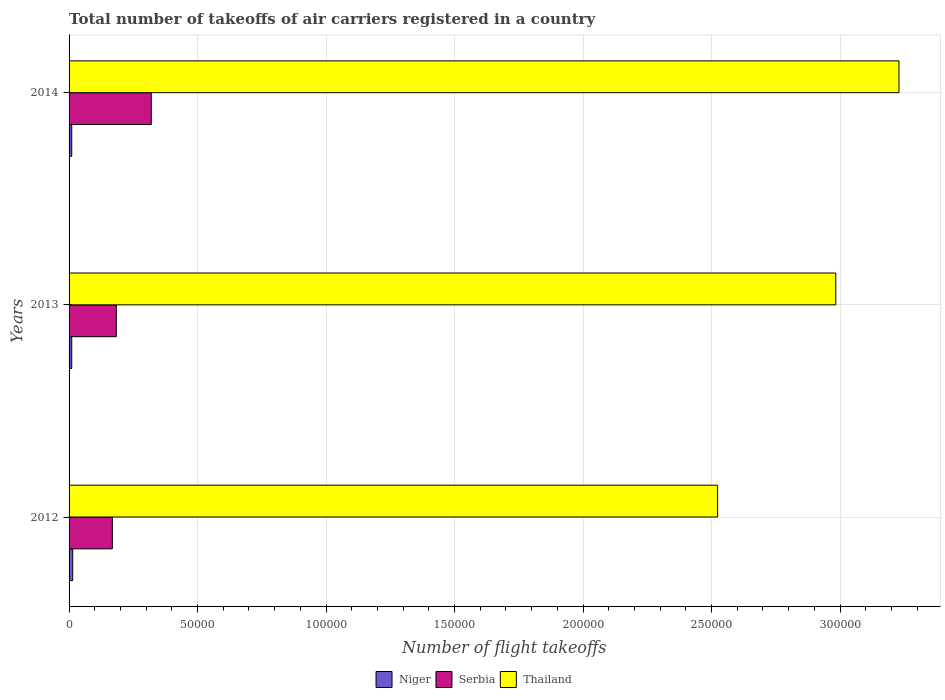How many different coloured bars are there?
Your answer should be compact. 3. How many groups of bars are there?
Offer a terse response. 3. How many bars are there on the 2nd tick from the top?
Provide a short and direct response. 3. In how many cases, is the number of bars for a given year not equal to the number of legend labels?
Offer a terse response. 0. What is the total number of flight takeoffs in Serbia in 2012?
Your answer should be compact. 1.68e+04. Across all years, what is the maximum total number of flight takeoffs in Serbia?
Keep it short and to the point. 3.20e+04. Across all years, what is the minimum total number of flight takeoffs in Thailand?
Your response must be concise. 2.52e+05. In which year was the total number of flight takeoffs in Serbia maximum?
Your answer should be very brief. 2014. What is the total total number of flight takeoffs in Niger in the graph?
Provide a short and direct response. 3496. What is the difference between the total number of flight takeoffs in Serbia in 2012 and that in 2013?
Give a very brief answer. -1546.04. What is the difference between the total number of flight takeoffs in Thailand in 2014 and the total number of flight takeoffs in Serbia in 2013?
Provide a succinct answer. 3.05e+05. What is the average total number of flight takeoffs in Thailand per year?
Provide a short and direct response. 2.91e+05. In the year 2014, what is the difference between the total number of flight takeoffs in Thailand and total number of flight takeoffs in Serbia?
Offer a terse response. 2.91e+05. In how many years, is the total number of flight takeoffs in Serbia greater than 10000 ?
Your answer should be very brief. 3. What is the ratio of the total number of flight takeoffs in Niger in 2012 to that in 2013?
Make the answer very short. 1.36. Is the total number of flight takeoffs in Thailand in 2012 less than that in 2014?
Provide a succinct answer. Yes. Is the difference between the total number of flight takeoffs in Thailand in 2012 and 2013 greater than the difference between the total number of flight takeoffs in Serbia in 2012 and 2013?
Keep it short and to the point. No. What is the difference between the highest and the second highest total number of flight takeoffs in Serbia?
Provide a short and direct response. 1.36e+04. What is the difference between the highest and the lowest total number of flight takeoffs in Serbia?
Your answer should be very brief. 1.51e+04. In how many years, is the total number of flight takeoffs in Thailand greater than the average total number of flight takeoffs in Thailand taken over all years?
Make the answer very short. 2. Is the sum of the total number of flight takeoffs in Thailand in 2013 and 2014 greater than the maximum total number of flight takeoffs in Niger across all years?
Your answer should be very brief. Yes. What does the 1st bar from the top in 2012 represents?
Provide a succinct answer. Thailand. What does the 3rd bar from the bottom in 2012 represents?
Provide a succinct answer. Thailand. How many bars are there?
Make the answer very short. 9. How many years are there in the graph?
Keep it short and to the point. 3. What is the difference between two consecutive major ticks on the X-axis?
Make the answer very short. 5.00e+04. Does the graph contain any zero values?
Keep it short and to the point. No. Does the graph contain grids?
Provide a succinct answer. Yes. How many legend labels are there?
Give a very brief answer. 3. How are the legend labels stacked?
Ensure brevity in your answer.  Horizontal. What is the title of the graph?
Your answer should be very brief. Total number of takeoffs of air carriers registered in a country. Does "Sao Tome and Principe" appear as one of the legend labels in the graph?
Your answer should be compact. No. What is the label or title of the X-axis?
Your response must be concise. Number of flight takeoffs. What is the Number of flight takeoffs in Niger in 2012?
Offer a very short reply. 1416. What is the Number of flight takeoffs in Serbia in 2012?
Your response must be concise. 1.68e+04. What is the Number of flight takeoffs of Thailand in 2012?
Provide a short and direct response. 2.52e+05. What is the Number of flight takeoffs in Niger in 2013?
Your answer should be very brief. 1040. What is the Number of flight takeoffs in Serbia in 2013?
Make the answer very short. 1.84e+04. What is the Number of flight takeoffs in Thailand in 2013?
Provide a short and direct response. 2.98e+05. What is the Number of flight takeoffs in Niger in 2014?
Ensure brevity in your answer.  1040. What is the Number of flight takeoffs in Serbia in 2014?
Provide a succinct answer. 3.20e+04. What is the Number of flight takeoffs in Thailand in 2014?
Your answer should be very brief. 3.23e+05. Across all years, what is the maximum Number of flight takeoffs of Niger?
Make the answer very short. 1416. Across all years, what is the maximum Number of flight takeoffs of Serbia?
Make the answer very short. 3.20e+04. Across all years, what is the maximum Number of flight takeoffs of Thailand?
Give a very brief answer. 3.23e+05. Across all years, what is the minimum Number of flight takeoffs in Niger?
Give a very brief answer. 1040. Across all years, what is the minimum Number of flight takeoffs in Serbia?
Your response must be concise. 1.68e+04. Across all years, what is the minimum Number of flight takeoffs of Thailand?
Provide a succinct answer. 2.52e+05. What is the total Number of flight takeoffs in Niger in the graph?
Offer a very short reply. 3496. What is the total Number of flight takeoffs of Serbia in the graph?
Your response must be concise. 6.72e+04. What is the total Number of flight takeoffs in Thailand in the graph?
Offer a terse response. 8.74e+05. What is the difference between the Number of flight takeoffs in Niger in 2012 and that in 2013?
Provide a short and direct response. 376. What is the difference between the Number of flight takeoffs of Serbia in 2012 and that in 2013?
Your answer should be very brief. -1546.04. What is the difference between the Number of flight takeoffs of Thailand in 2012 and that in 2013?
Provide a short and direct response. -4.60e+04. What is the difference between the Number of flight takeoffs in Niger in 2012 and that in 2014?
Ensure brevity in your answer.  376. What is the difference between the Number of flight takeoffs of Serbia in 2012 and that in 2014?
Offer a very short reply. -1.51e+04. What is the difference between the Number of flight takeoffs in Thailand in 2012 and that in 2014?
Offer a terse response. -7.06e+04. What is the difference between the Number of flight takeoffs in Serbia in 2013 and that in 2014?
Your answer should be very brief. -1.36e+04. What is the difference between the Number of flight takeoffs of Thailand in 2013 and that in 2014?
Offer a terse response. -2.46e+04. What is the difference between the Number of flight takeoffs in Niger in 2012 and the Number of flight takeoffs in Serbia in 2013?
Provide a succinct answer. -1.70e+04. What is the difference between the Number of flight takeoffs in Niger in 2012 and the Number of flight takeoffs in Thailand in 2013?
Keep it short and to the point. -2.97e+05. What is the difference between the Number of flight takeoffs of Serbia in 2012 and the Number of flight takeoffs of Thailand in 2013?
Offer a very short reply. -2.82e+05. What is the difference between the Number of flight takeoffs of Niger in 2012 and the Number of flight takeoffs of Serbia in 2014?
Provide a short and direct response. -3.06e+04. What is the difference between the Number of flight takeoffs of Niger in 2012 and the Number of flight takeoffs of Thailand in 2014?
Offer a terse response. -3.22e+05. What is the difference between the Number of flight takeoffs in Serbia in 2012 and the Number of flight takeoffs in Thailand in 2014?
Provide a short and direct response. -3.06e+05. What is the difference between the Number of flight takeoffs in Niger in 2013 and the Number of flight takeoffs in Serbia in 2014?
Offer a terse response. -3.09e+04. What is the difference between the Number of flight takeoffs in Niger in 2013 and the Number of flight takeoffs in Thailand in 2014?
Provide a succinct answer. -3.22e+05. What is the difference between the Number of flight takeoffs of Serbia in 2013 and the Number of flight takeoffs of Thailand in 2014?
Offer a very short reply. -3.05e+05. What is the average Number of flight takeoffs in Niger per year?
Your answer should be very brief. 1165.33. What is the average Number of flight takeoffs of Serbia per year?
Give a very brief answer. 2.24e+04. What is the average Number of flight takeoffs of Thailand per year?
Provide a short and direct response. 2.91e+05. In the year 2012, what is the difference between the Number of flight takeoffs of Niger and Number of flight takeoffs of Serbia?
Your response must be concise. -1.54e+04. In the year 2012, what is the difference between the Number of flight takeoffs of Niger and Number of flight takeoffs of Thailand?
Your answer should be compact. -2.51e+05. In the year 2012, what is the difference between the Number of flight takeoffs in Serbia and Number of flight takeoffs in Thailand?
Offer a terse response. -2.36e+05. In the year 2013, what is the difference between the Number of flight takeoffs of Niger and Number of flight takeoffs of Serbia?
Keep it short and to the point. -1.73e+04. In the year 2013, what is the difference between the Number of flight takeoffs of Niger and Number of flight takeoffs of Thailand?
Give a very brief answer. -2.97e+05. In the year 2013, what is the difference between the Number of flight takeoffs in Serbia and Number of flight takeoffs in Thailand?
Your response must be concise. -2.80e+05. In the year 2014, what is the difference between the Number of flight takeoffs in Niger and Number of flight takeoffs in Serbia?
Ensure brevity in your answer.  -3.09e+04. In the year 2014, what is the difference between the Number of flight takeoffs of Niger and Number of flight takeoffs of Thailand?
Ensure brevity in your answer.  -3.22e+05. In the year 2014, what is the difference between the Number of flight takeoffs of Serbia and Number of flight takeoffs of Thailand?
Offer a very short reply. -2.91e+05. What is the ratio of the Number of flight takeoffs in Niger in 2012 to that in 2013?
Your answer should be compact. 1.36. What is the ratio of the Number of flight takeoffs in Serbia in 2012 to that in 2013?
Provide a succinct answer. 0.92. What is the ratio of the Number of flight takeoffs in Thailand in 2012 to that in 2013?
Offer a very short reply. 0.85. What is the ratio of the Number of flight takeoffs in Niger in 2012 to that in 2014?
Your answer should be very brief. 1.36. What is the ratio of the Number of flight takeoffs in Serbia in 2012 to that in 2014?
Provide a succinct answer. 0.53. What is the ratio of the Number of flight takeoffs of Thailand in 2012 to that in 2014?
Your answer should be very brief. 0.78. What is the ratio of the Number of flight takeoffs of Niger in 2013 to that in 2014?
Your response must be concise. 1. What is the ratio of the Number of flight takeoffs in Serbia in 2013 to that in 2014?
Make the answer very short. 0.57. What is the ratio of the Number of flight takeoffs of Thailand in 2013 to that in 2014?
Provide a succinct answer. 0.92. What is the difference between the highest and the second highest Number of flight takeoffs in Niger?
Provide a short and direct response. 376. What is the difference between the highest and the second highest Number of flight takeoffs in Serbia?
Your answer should be compact. 1.36e+04. What is the difference between the highest and the second highest Number of flight takeoffs in Thailand?
Keep it short and to the point. 2.46e+04. What is the difference between the highest and the lowest Number of flight takeoffs of Niger?
Your response must be concise. 376. What is the difference between the highest and the lowest Number of flight takeoffs in Serbia?
Offer a very short reply. 1.51e+04. What is the difference between the highest and the lowest Number of flight takeoffs in Thailand?
Your response must be concise. 7.06e+04. 